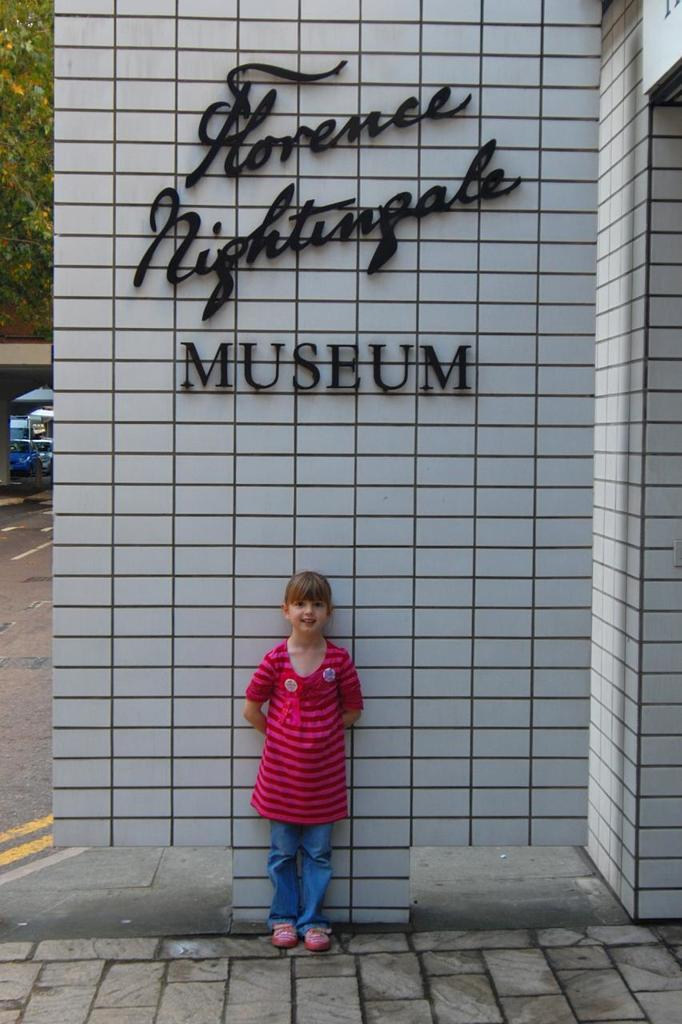Who is the main subject in the image? There is a girl in the image. What is the girl wearing? The girl is wearing a pink top and jeans. What is behind the girl in the image? There is a wall behind the girl. What is written on the wall? The word "museum" is written on the wall. What can be seen in the distance in the image? There is a road visible in the image. What type of vegetation is on the left side of the image? There are trees on the left side of the image. What type of nut is the girl holding in the image? There is no nut present in the image. How does the girl show respect in the image? The image does not depict the girl showing respect, nor is there any indication of her doing so. 